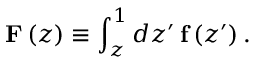Convert formula to latex. <formula><loc_0><loc_0><loc_500><loc_500>F \left ( z \right ) \equiv \int _ { z } ^ { 1 } d z ^ { \prime } \, f \left ( z ^ { \prime } \right ) .</formula> 